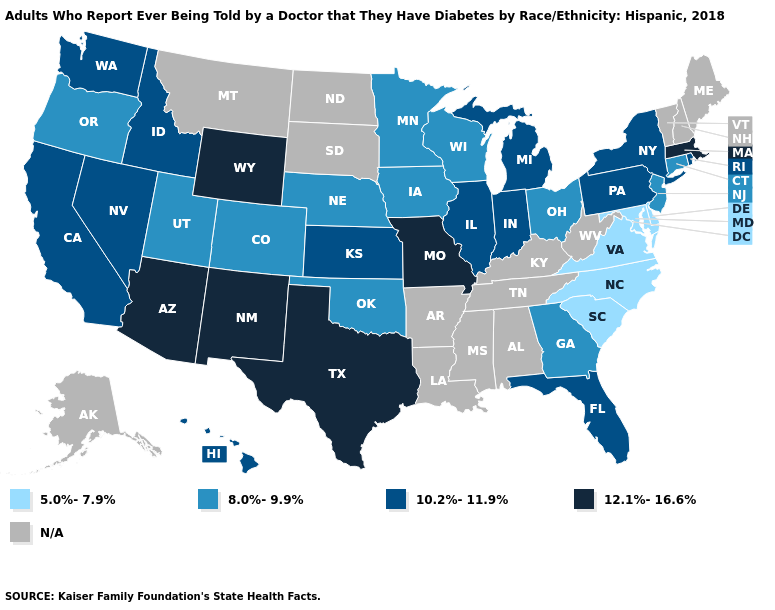Which states have the highest value in the USA?
Be succinct. Arizona, Massachusetts, Missouri, New Mexico, Texas, Wyoming. Name the states that have a value in the range N/A?
Quick response, please. Alabama, Alaska, Arkansas, Kentucky, Louisiana, Maine, Mississippi, Montana, New Hampshire, North Dakota, South Dakota, Tennessee, Vermont, West Virginia. What is the value of Indiana?
Concise answer only. 10.2%-11.9%. What is the value of Utah?
Give a very brief answer. 8.0%-9.9%. What is the highest value in the USA?
Quick response, please. 12.1%-16.6%. Which states have the lowest value in the USA?
Be succinct. Delaware, Maryland, North Carolina, South Carolina, Virginia. What is the value of Texas?
Answer briefly. 12.1%-16.6%. What is the value of Alabama?
Write a very short answer. N/A. What is the highest value in the USA?
Write a very short answer. 12.1%-16.6%. What is the lowest value in the USA?
Be succinct. 5.0%-7.9%. What is the value of North Dakota?
Short answer required. N/A. What is the highest value in states that border North Dakota?
Keep it brief. 8.0%-9.9%. Among the states that border South Dakota , which have the lowest value?
Answer briefly. Iowa, Minnesota, Nebraska. Name the states that have a value in the range N/A?
Short answer required. Alabama, Alaska, Arkansas, Kentucky, Louisiana, Maine, Mississippi, Montana, New Hampshire, North Dakota, South Dakota, Tennessee, Vermont, West Virginia. What is the lowest value in states that border Montana?
Be succinct. 10.2%-11.9%. 